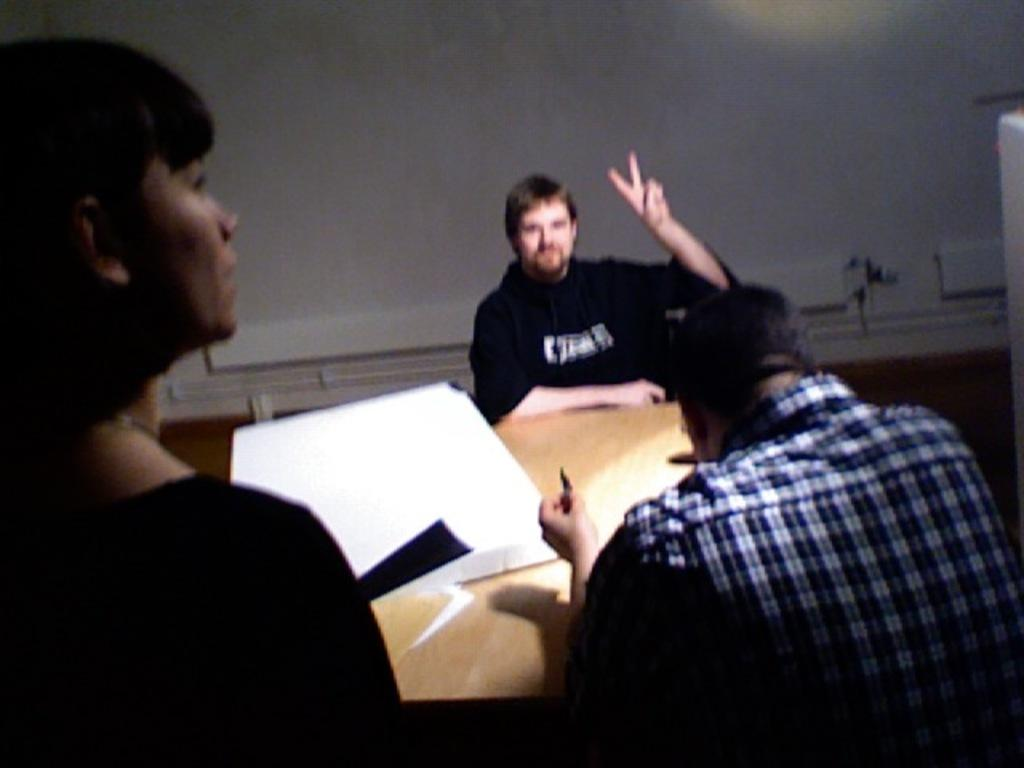What are the men in the image doing? The men in the image are seated on chairs. What is the woman in the image doing? The woman in the image is standing. What object can be seen on a table in the image? There is a box on a table in the image. What color is the wall in the background of the image? The wall in the background of the image is white. What type of juice is being served to the men in the image? There is no juice present in the image; the men are seated on chairs and the woman is standing. 